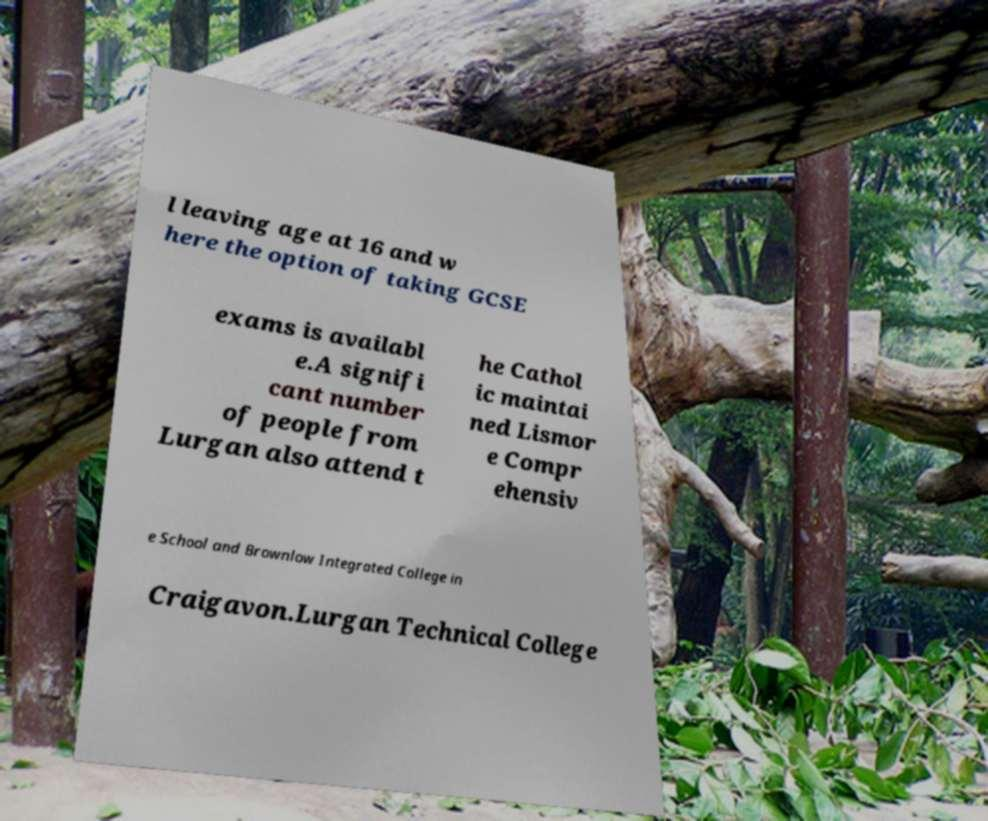What messages or text are displayed in this image? I need them in a readable, typed format. l leaving age at 16 and w here the option of taking GCSE exams is availabl e.A signifi cant number of people from Lurgan also attend t he Cathol ic maintai ned Lismor e Compr ehensiv e School and Brownlow Integrated College in Craigavon.Lurgan Technical College 